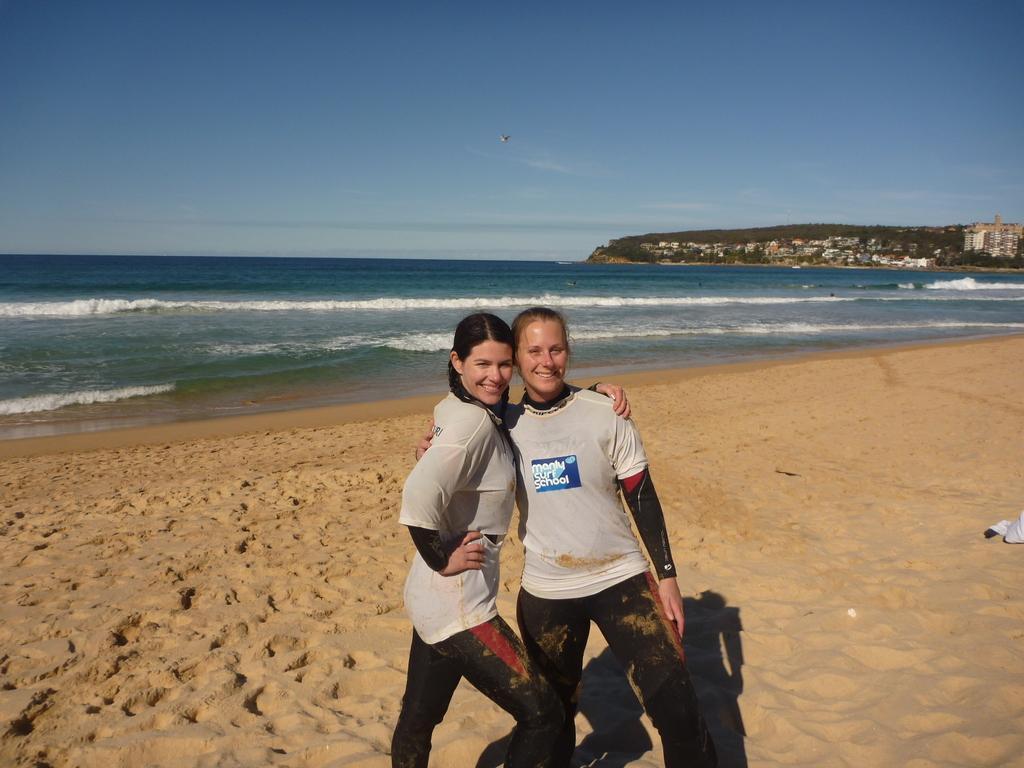Describe this image in one or two sentences. In this image, we can see people and in the background, there are buildings, trees and hills. At the top, there is an airplane in the sky and at the bottom, there is water and sand. 